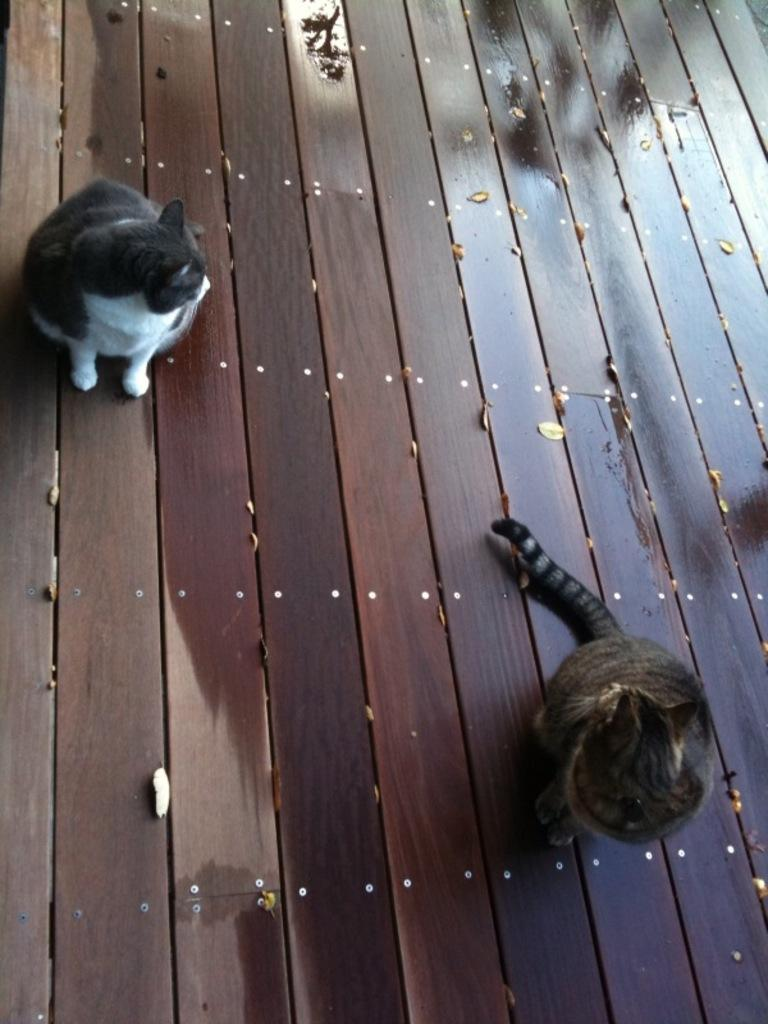How many cats are visible in the image? There are two cats visible in the image, one on the left side and one on the right side. Can you describe the position of the cats in the image? Both cats are on the ground, with one on the left side and one on the right side. What type of nut is being cracked by the cat on the left side of the image? There is no nut present in the image, and neither cat is shown cracking a nut. 